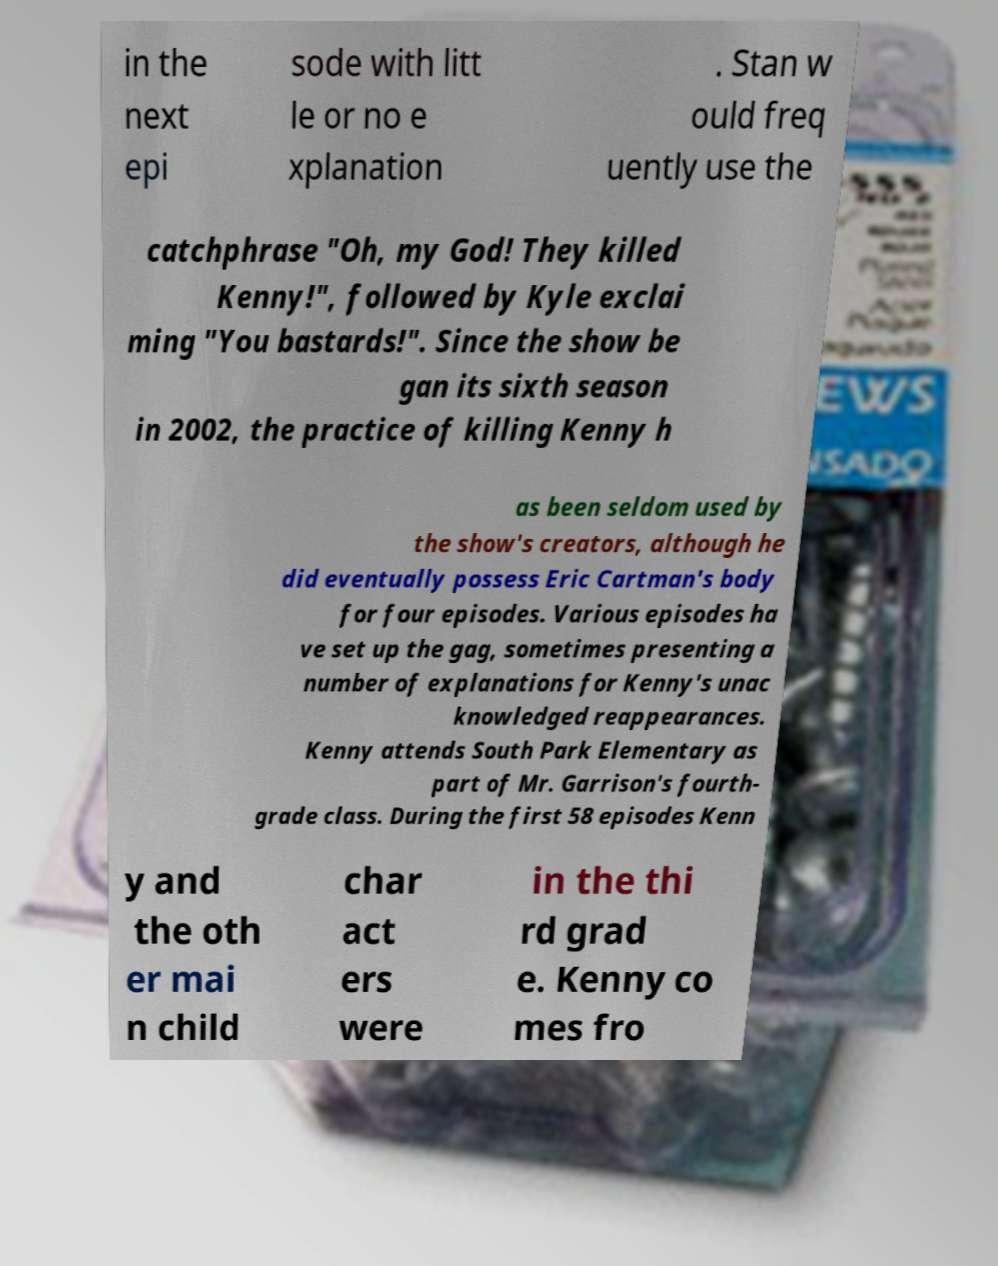There's text embedded in this image that I need extracted. Can you transcribe it verbatim? in the next epi sode with litt le or no e xplanation . Stan w ould freq uently use the catchphrase "Oh, my God! They killed Kenny!", followed by Kyle exclai ming "You bastards!". Since the show be gan its sixth season in 2002, the practice of killing Kenny h as been seldom used by the show's creators, although he did eventually possess Eric Cartman's body for four episodes. Various episodes ha ve set up the gag, sometimes presenting a number of explanations for Kenny's unac knowledged reappearances. Kenny attends South Park Elementary as part of Mr. Garrison's fourth- grade class. During the first 58 episodes Kenn y and the oth er mai n child char act ers were in the thi rd grad e. Kenny co mes fro 